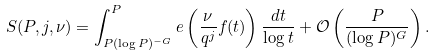Convert formula to latex. <formula><loc_0><loc_0><loc_500><loc_500>S ( P , j , \nu ) = \int _ { P ( \log P ) ^ { - G } } ^ { P } e \left ( \frac { \nu } { q ^ { j } } f ( t ) \right ) \frac { d t } { \log t } + \mathcal { O } \left ( \frac { P } { ( \log P ) ^ { G } } \right ) .</formula> 